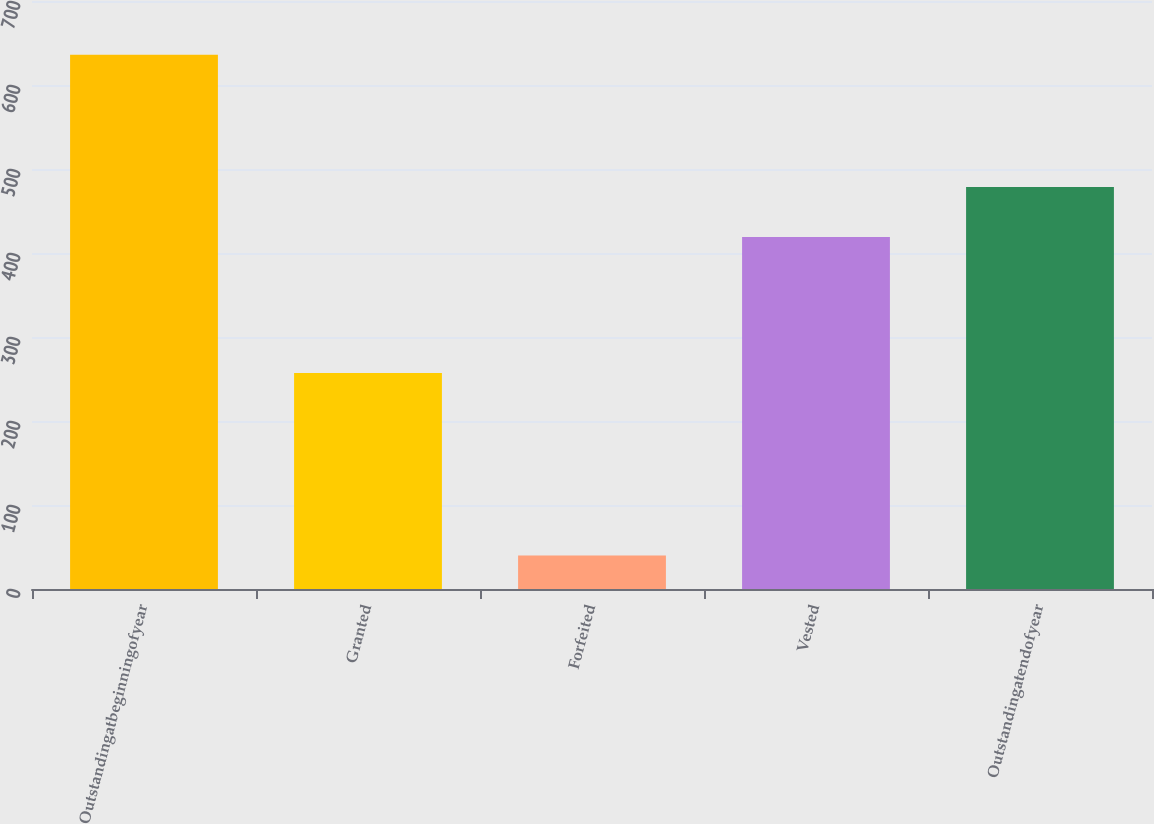Convert chart to OTSL. <chart><loc_0><loc_0><loc_500><loc_500><bar_chart><fcel>Outstandingatbeginningofyear<fcel>Granted<fcel>Forfeited<fcel>Vested<fcel>Outstandingatendofyear<nl><fcel>636<fcel>257<fcel>40<fcel>419<fcel>478.6<nl></chart> 